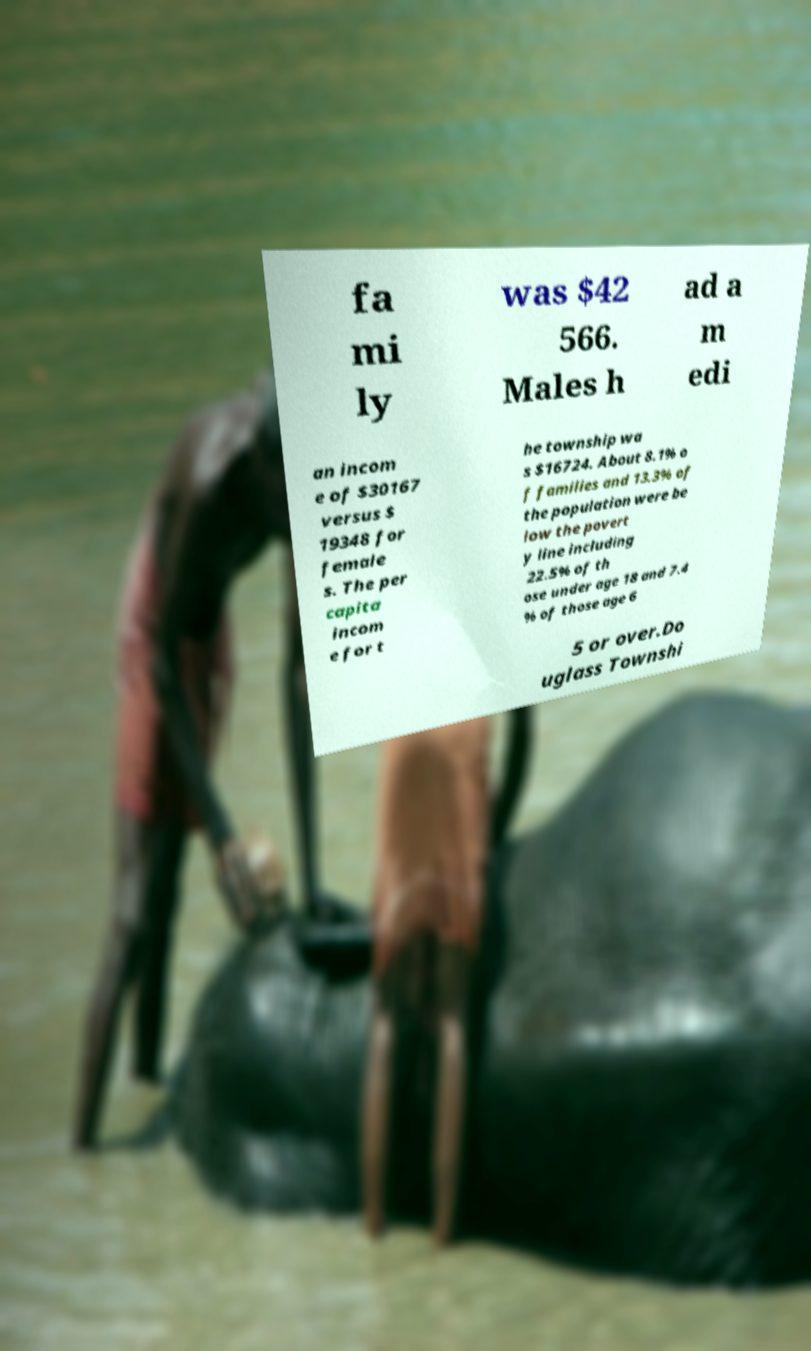Can you accurately transcribe the text from the provided image for me? fa mi ly was $42 566. Males h ad a m edi an incom e of $30167 versus $ 19348 for female s. The per capita incom e for t he township wa s $16724. About 8.1% o f families and 13.3% of the population were be low the povert y line including 22.5% of th ose under age 18 and 7.4 % of those age 6 5 or over.Do uglass Townshi 